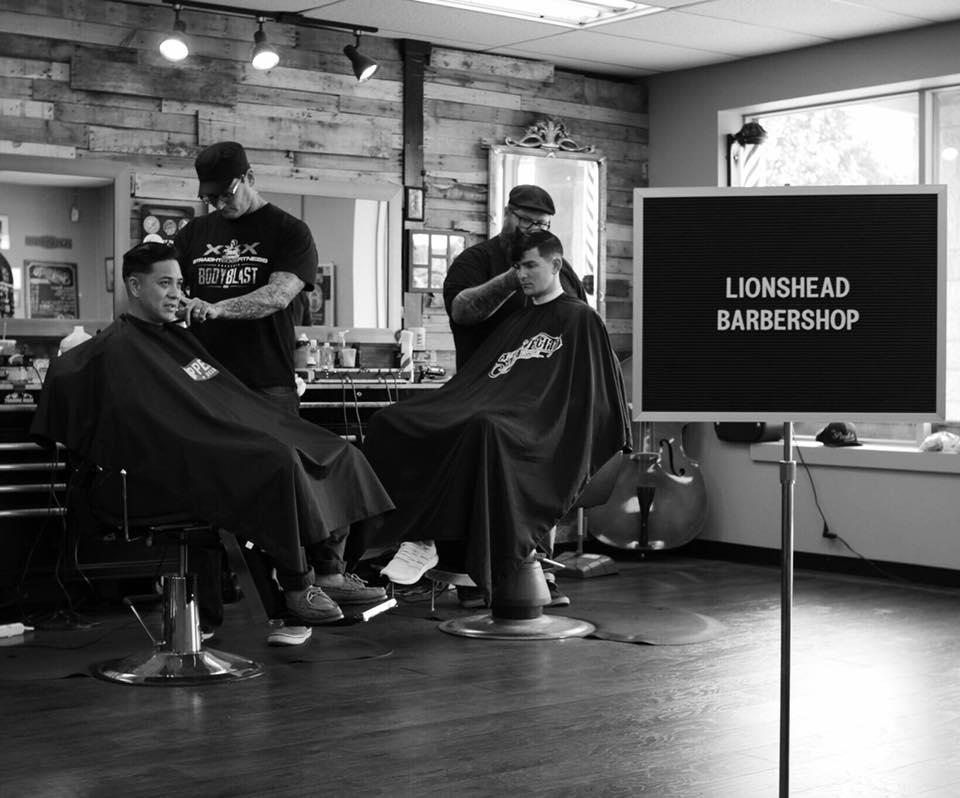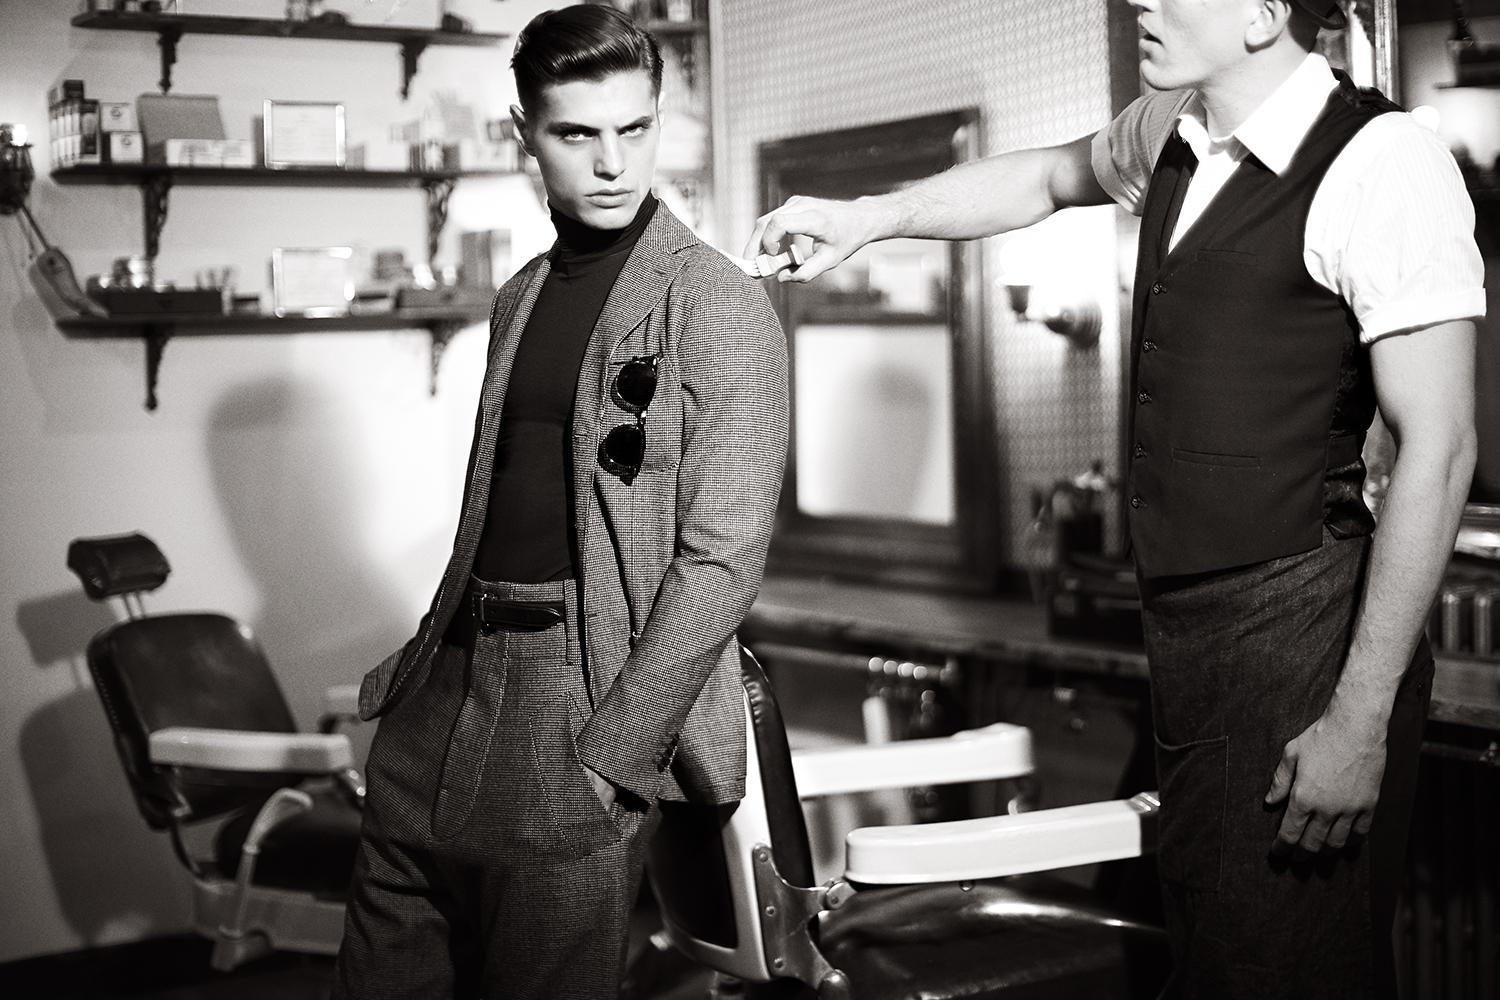The first image is the image on the left, the second image is the image on the right. For the images shown, is this caption "All of these images are in black and white." true? Answer yes or no. Yes. The first image is the image on the left, the second image is the image on the right. For the images shown, is this caption "The left image includes a man in a hat, glasses and beard standing behind a forward-facing customer in a black smock." true? Answer yes or no. Yes. 